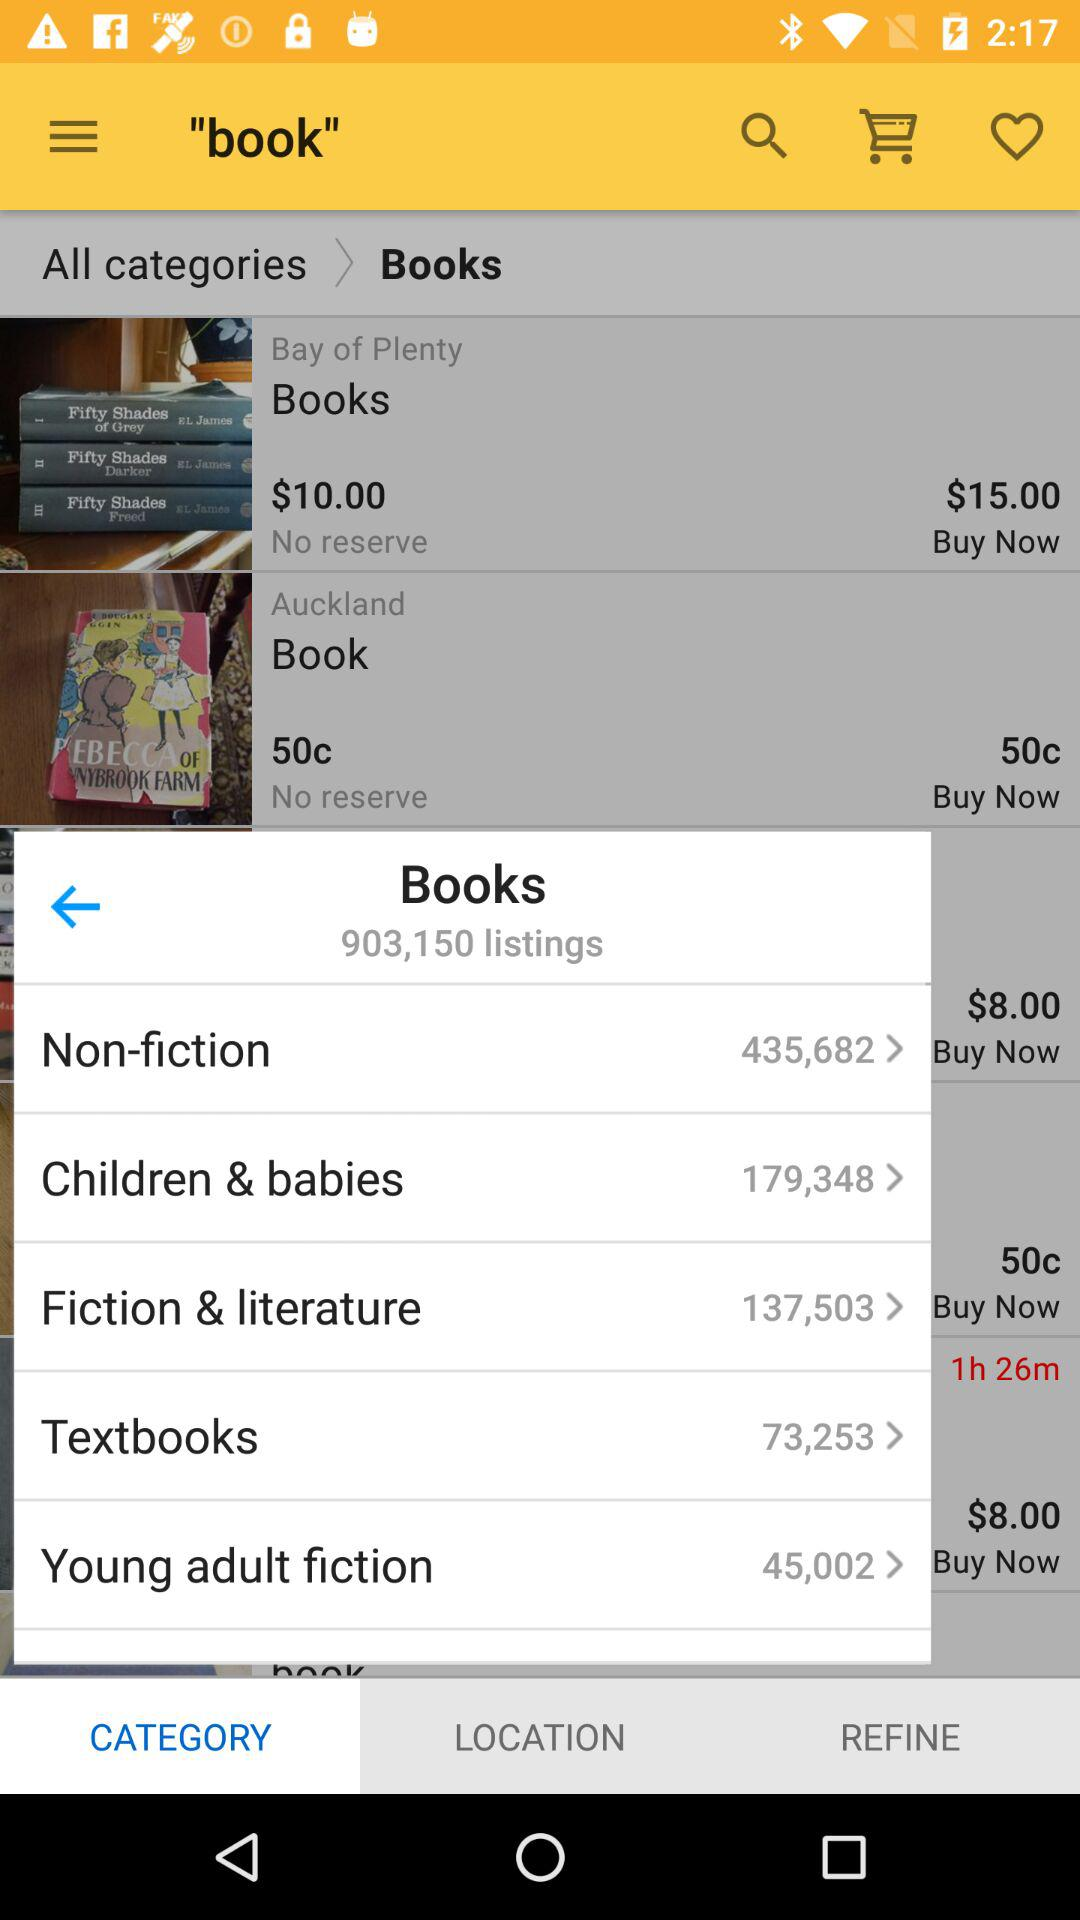Which tab of "book" is open? The open tabs are "Books" and "CATEGORY". 